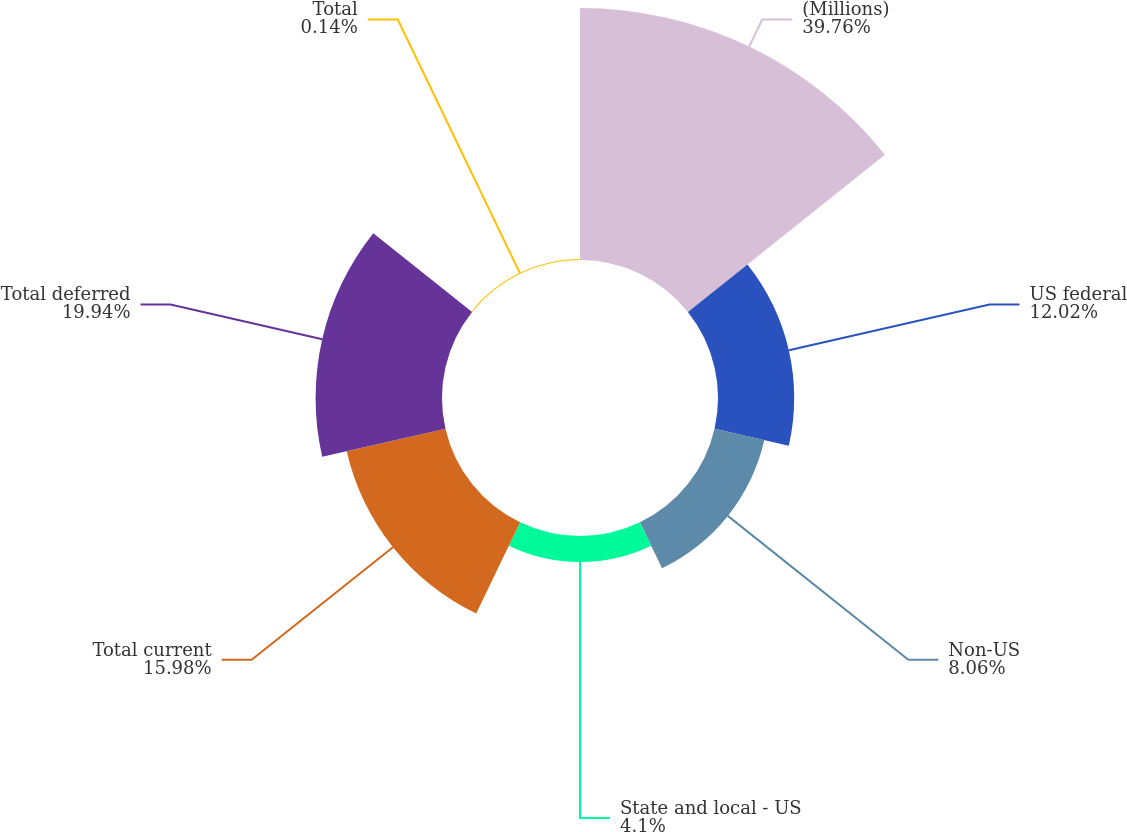Convert chart. <chart><loc_0><loc_0><loc_500><loc_500><pie_chart><fcel>(Millions)<fcel>US federal<fcel>Non-US<fcel>State and local - US<fcel>Total current<fcel>Total deferred<fcel>Total<nl><fcel>39.75%<fcel>12.02%<fcel>8.06%<fcel>4.1%<fcel>15.98%<fcel>19.94%<fcel>0.14%<nl></chart> 